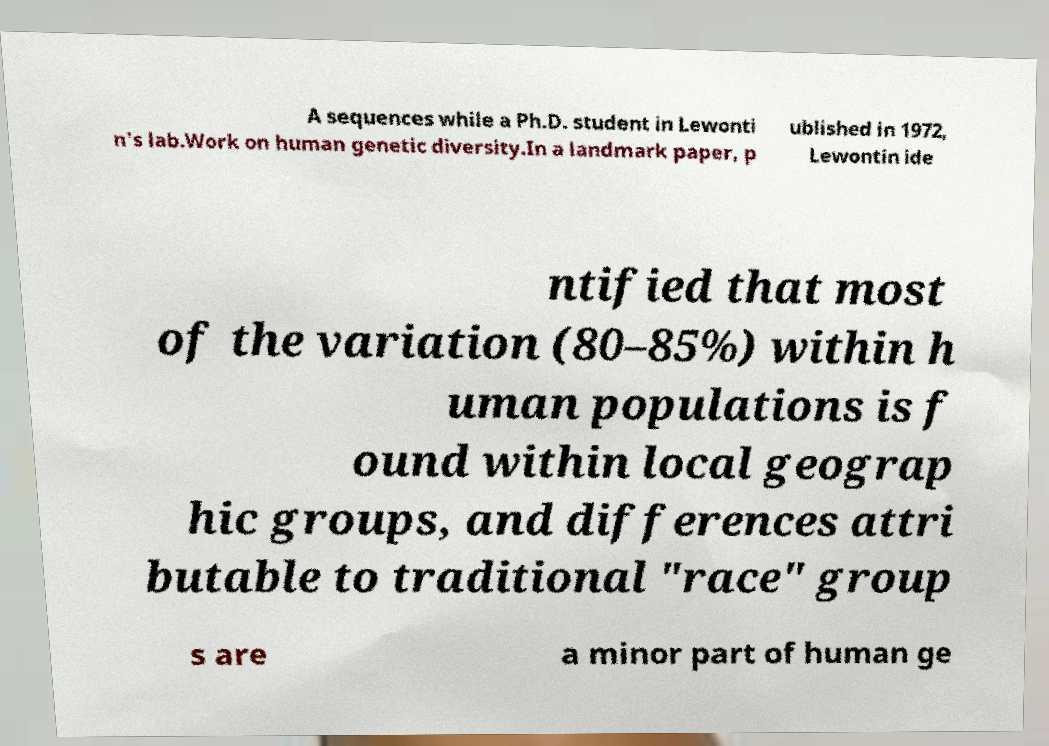What messages or text are displayed in this image? I need them in a readable, typed format. A sequences while a Ph.D. student in Lewonti n's lab.Work on human genetic diversity.In a landmark paper, p ublished in 1972, Lewontin ide ntified that most of the variation (80–85%) within h uman populations is f ound within local geograp hic groups, and differences attri butable to traditional "race" group s are a minor part of human ge 